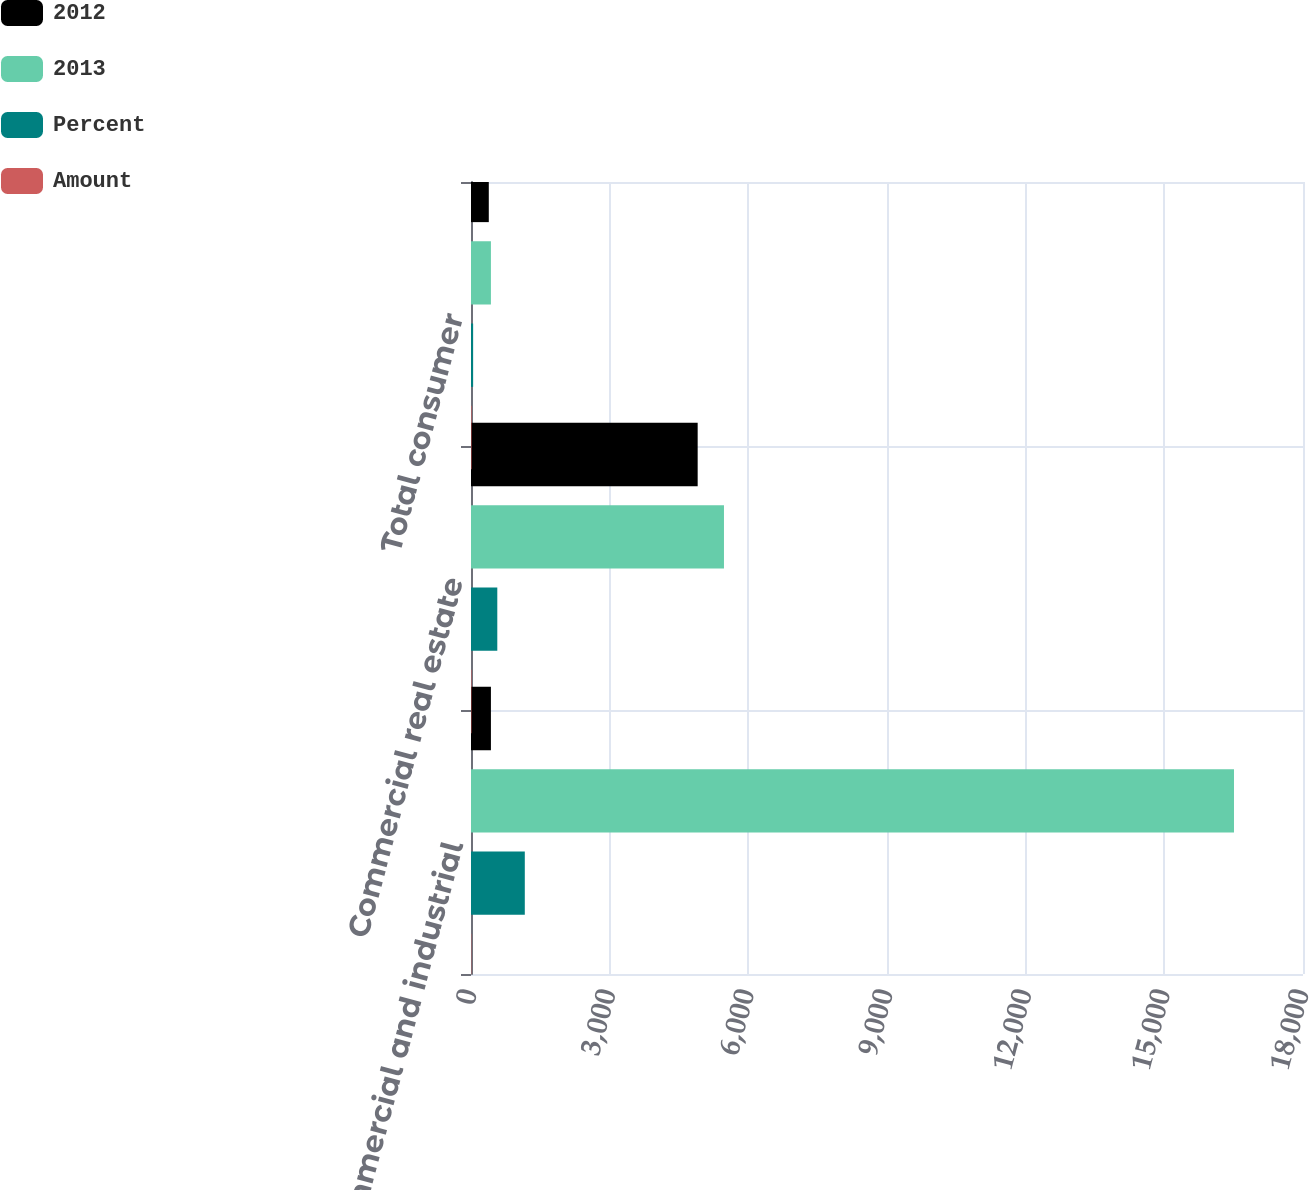Convert chart. <chart><loc_0><loc_0><loc_500><loc_500><stacked_bar_chart><ecel><fcel>Commercial and industrial<fcel>Commercial real estate<fcel>Total consumer<nl><fcel>2012<fcel>431<fcel>4904<fcel>385<nl><fcel>2013<fcel>16507<fcel>5473<fcel>431<nl><fcel>Percent<fcel>1164<fcel>569<fcel>46<nl><fcel>Amount<fcel>7<fcel>10<fcel>12<nl></chart> 